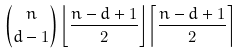<formula> <loc_0><loc_0><loc_500><loc_500>\binom { n } { d - 1 } \left \lfloor \frac { n - d + 1 } { 2 } \right \rfloor \left \lceil \frac { n - d + 1 } { 2 } \right \rceil</formula> 